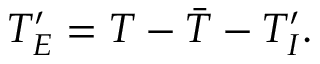<formula> <loc_0><loc_0><loc_500><loc_500>{ T } _ { E } ^ { \prime } = T - \bar { T } - { T } _ { I } ^ { \prime } .</formula> 